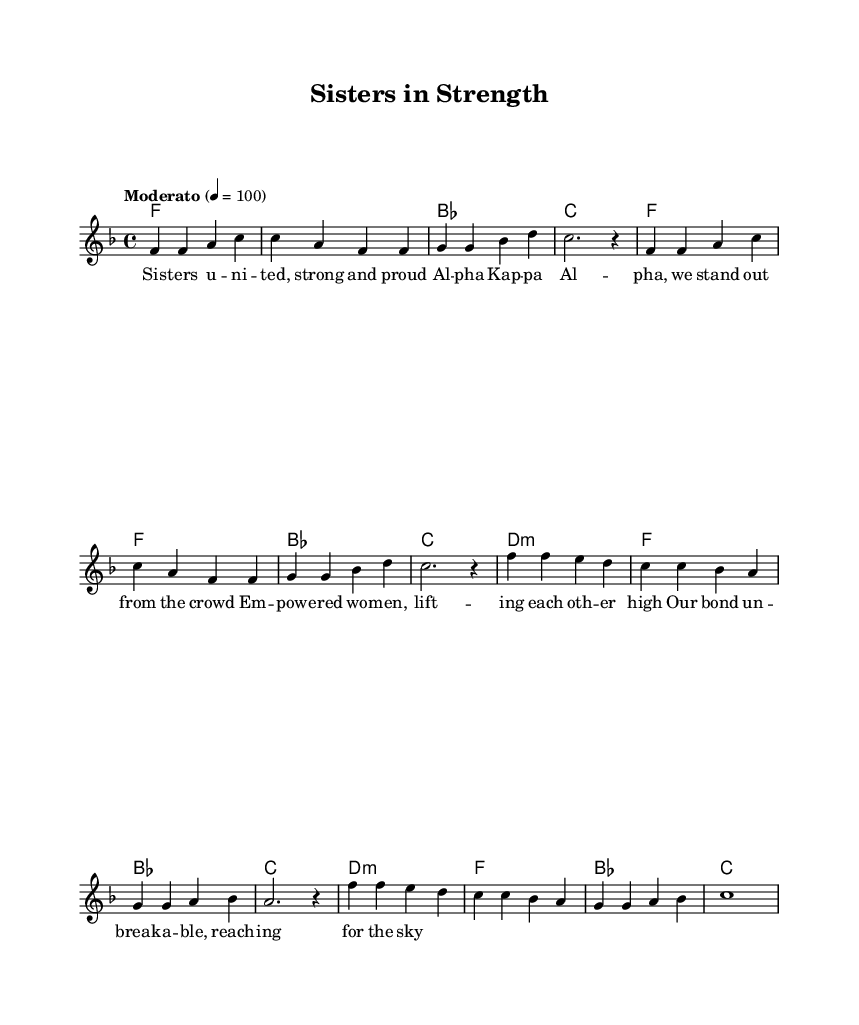What is the key signature of this music? The key signature is identified at the beginning of the staff. Here, it shows one flat, indicating that it is in F major.
Answer: F major What is the time signature of this music? The time signature is located right after the key signature. In this case, it shows 4/4, which means there are four beats in a measure.
Answer: 4/4 What is the tempo marking for this piece? The tempo is indicated by the word "Moderato," which suggests a moderate pace. This provides the performer with guidance on how fast to play the piece.
Answer: Moderato How many measures are in the melody? By counting the distinct groups of notes separated by vertical lines (bar lines), we find there are eight measures within the melody.
Answer: Eight What are the main lyrical themes of the song? The lyrics describe unity, strength, empowerment, and sisterhood among members of Alpha Kappa Alpha. They emphasize pride and support for one another throughout the text.
Answer: Unity and empowerment Which chords are used in the harmony section? Analyzing the chord symbols given in the harmony section reveals the chords F, B flat, C, and D minor. These reflect common chords found in R&B music.
Answer: F, B flat, C, D minor What does the phrase "unbreakable bond" likely symbolize in the context of the lyrics? The phrase "unbreakable bond" symbolizes the strong connections between sorority sisters, highlighting their lifelong friendship and support system in the context of sisterhood.
Answer: Sisterhood 